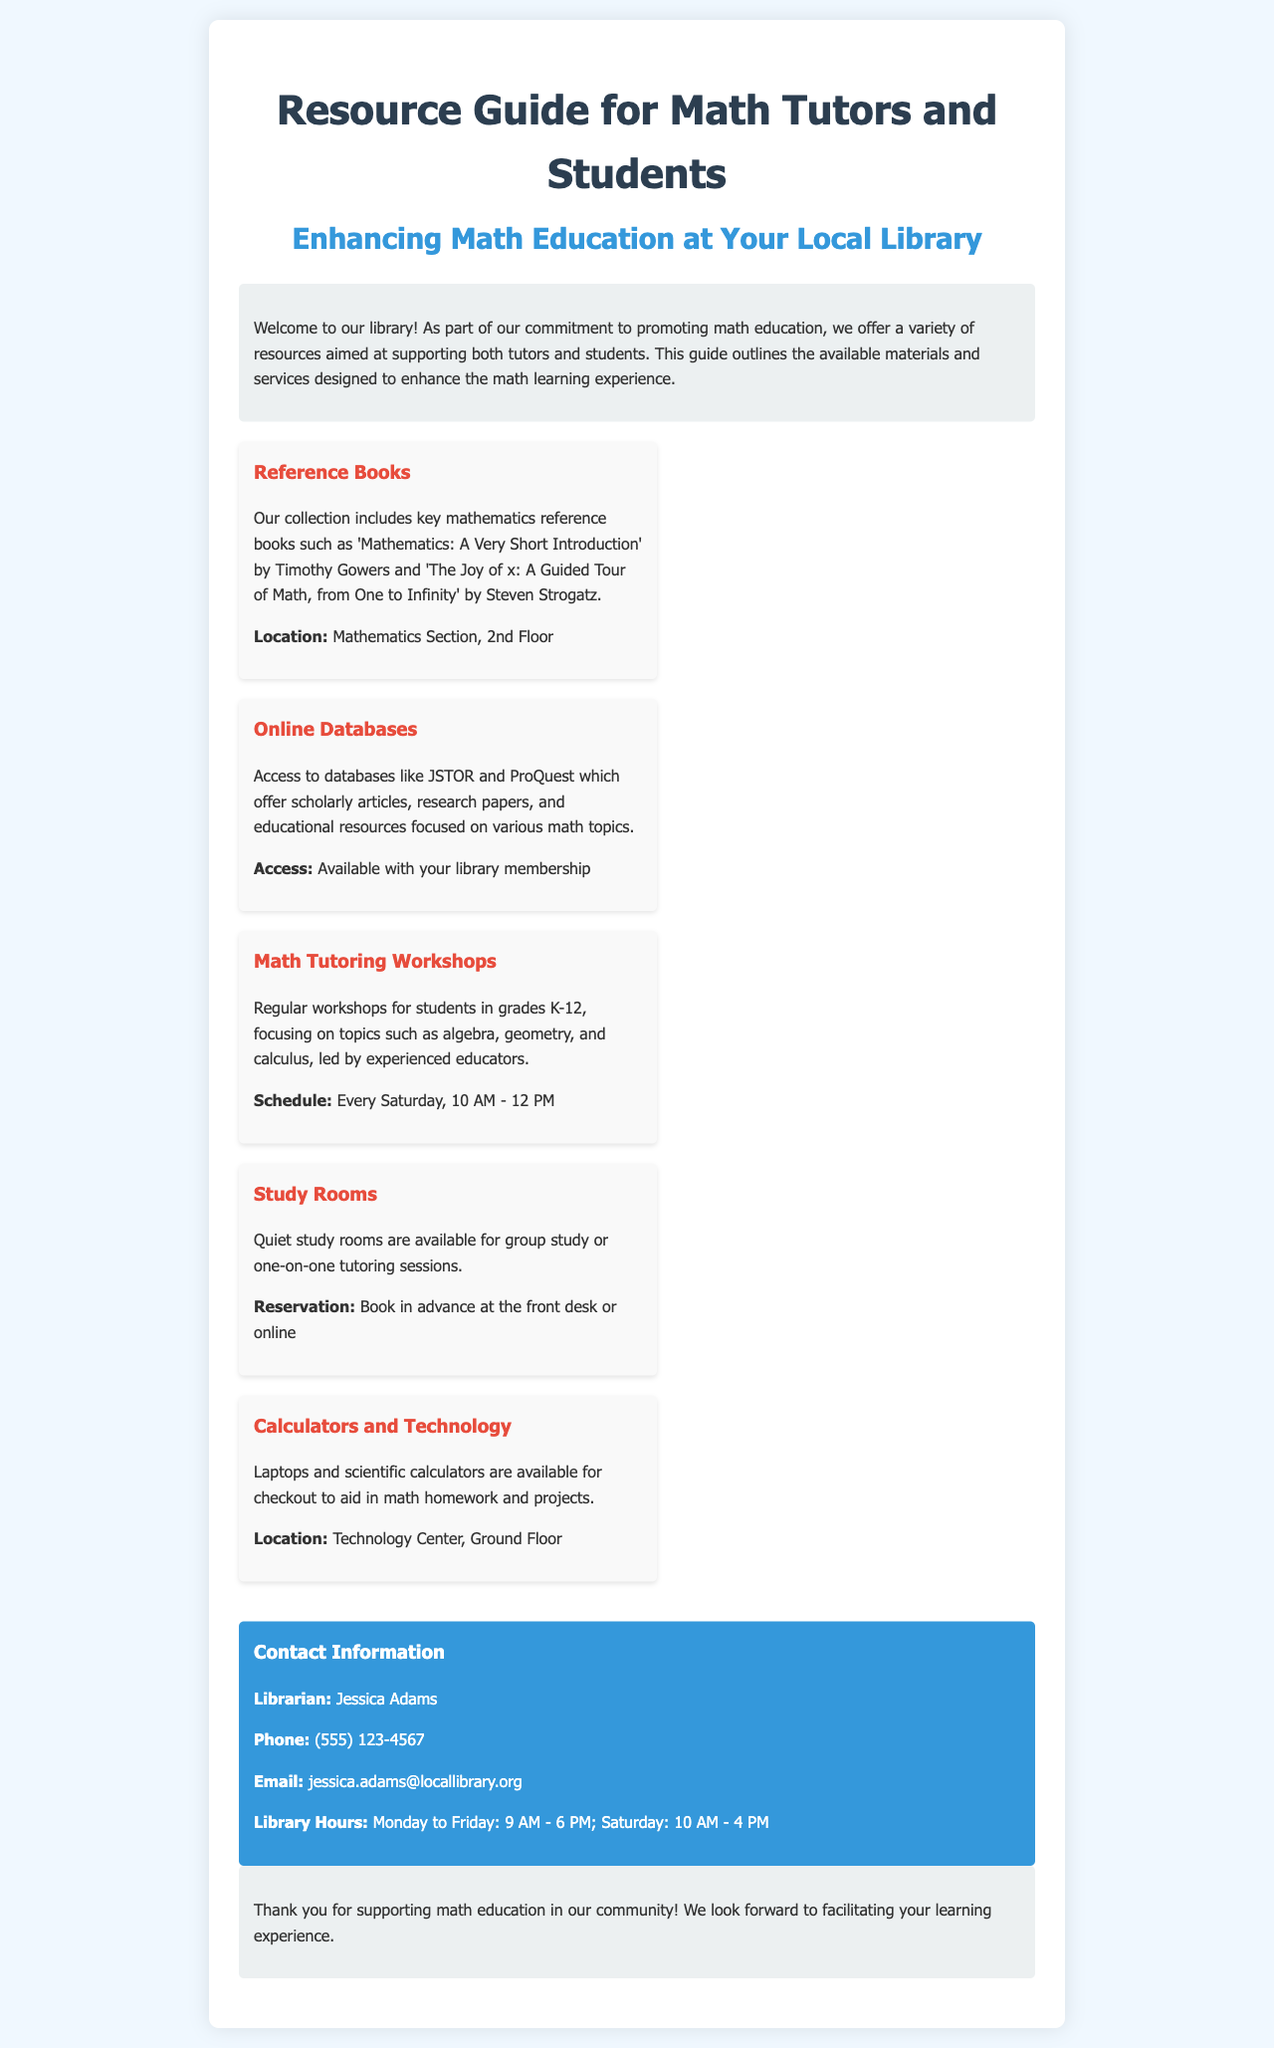What is the title of the guide? The title of the guide is clearly stated at the top of the document.
Answer: Resource Guide for Math Tutors and Students Who is the librarian's contact? The document specifies the librarian's name in the contact information section.
Answer: Jessica Adams What day are math tutoring workshops held? The schedule for the workshops is provided in the resources section.
Answer: Every Saturday What is one reference book mentioned? The document lists several reference books in the resources section.
Answer: Mathematics: A Very Short Introduction What is the phone number for the library? The phone number is included in the contact information section.
Answer: (555) 123-4567 How often are math tutoring workshops scheduled? The frequency of the workshops is indicated in the schedule mention.
Answer: Weekly Where can calculators be found? The location of calculators is indicated in the resources section.
Answer: Technology Center, Ground Floor What are the library hours on Saturday? The document provides library hours in the contact information section.
Answer: 10 AM - 4 PM 